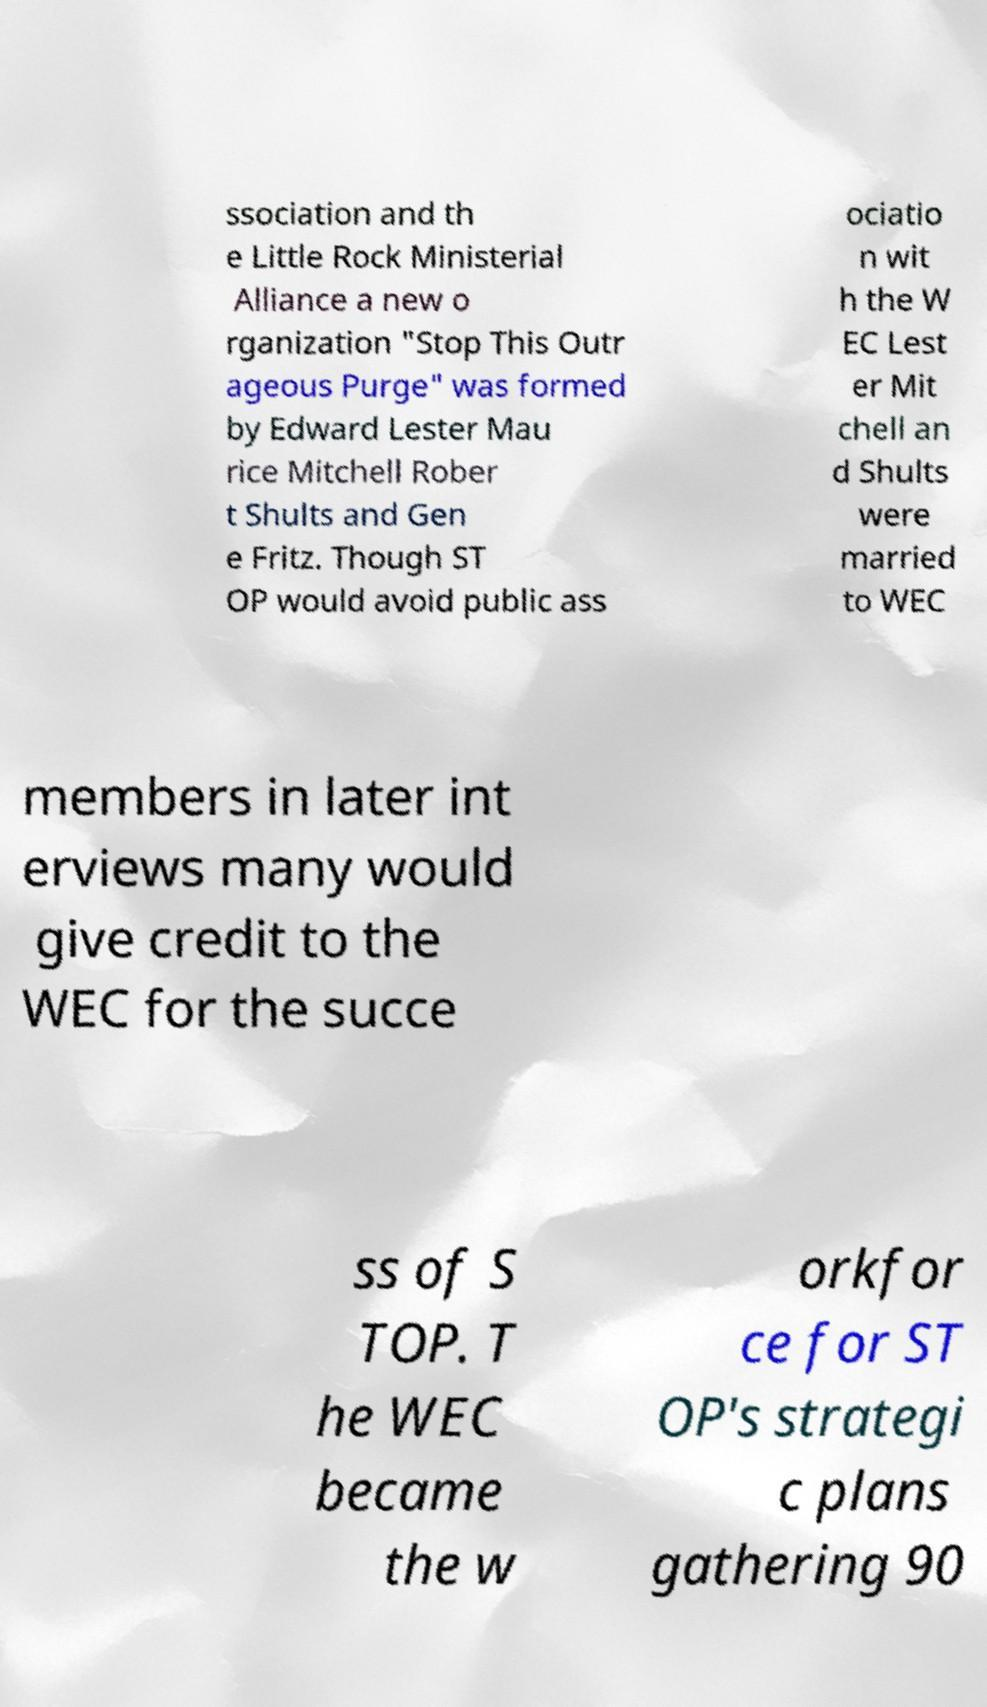Can you accurately transcribe the text from the provided image for me? ssociation and th e Little Rock Ministerial Alliance a new o rganization "Stop This Outr ageous Purge" was formed by Edward Lester Mau rice Mitchell Rober t Shults and Gen e Fritz. Though ST OP would avoid public ass ociatio n wit h the W EC Lest er Mit chell an d Shults were married to WEC members in later int erviews many would give credit to the WEC for the succe ss of S TOP. T he WEC became the w orkfor ce for ST OP's strategi c plans gathering 90 